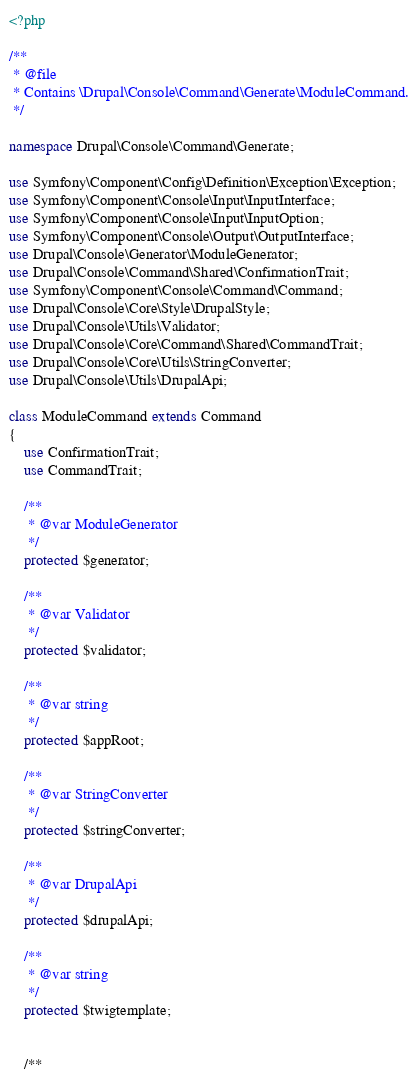Convert code to text. <code><loc_0><loc_0><loc_500><loc_500><_PHP_><?php

/**
 * @file
 * Contains \Drupal\Console\Command\Generate\ModuleCommand.
 */

namespace Drupal\Console\Command\Generate;

use Symfony\Component\Config\Definition\Exception\Exception;
use Symfony\Component\Console\Input\InputInterface;
use Symfony\Component\Console\Input\InputOption;
use Symfony\Component\Console\Output\OutputInterface;
use Drupal\Console\Generator\ModuleGenerator;
use Drupal\Console\Command\Shared\ConfirmationTrait;
use Symfony\Component\Console\Command\Command;
use Drupal\Console\Core\Style\DrupalStyle;
use Drupal\Console\Utils\Validator;
use Drupal\Console\Core\Command\Shared\CommandTrait;
use Drupal\Console\Core\Utils\StringConverter;
use Drupal\Console\Utils\DrupalApi;

class ModuleCommand extends Command
{
    use ConfirmationTrait;
    use CommandTrait;

    /**
     * @var ModuleGenerator
     */
    protected $generator;

    /**
     * @var Validator
     */
    protected $validator;

    /**
     * @var string
     */
    protected $appRoot;

    /**
     * @var StringConverter
     */
    protected $stringConverter;

    /**
     * @var DrupalApi
     */
    protected $drupalApi;

    /**
     * @var string
     */
    protected $twigtemplate;


    /**</code> 